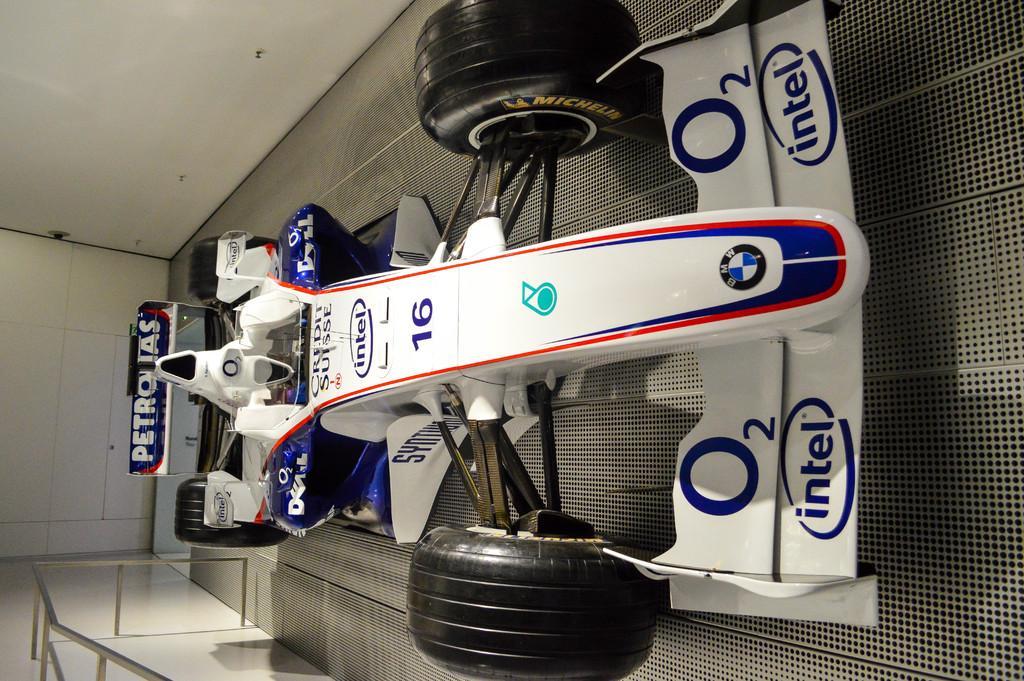Could you give a brief overview of what you see in this image? In this image in the front there is a racing car which is white and blue in colour with some text and numbers written on it and at the the bottom left there is railing on the wall. 